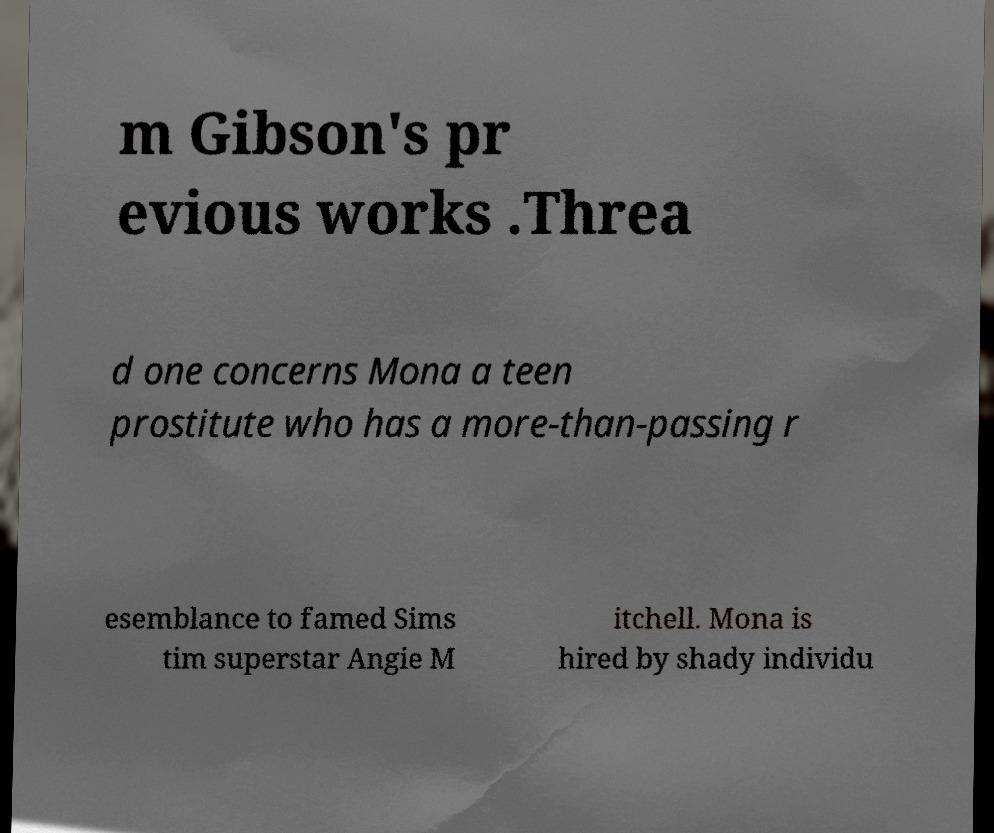There's text embedded in this image that I need extracted. Can you transcribe it verbatim? m Gibson's pr evious works .Threa d one concerns Mona a teen prostitute who has a more-than-passing r esemblance to famed Sims tim superstar Angie M itchell. Mona is hired by shady individu 